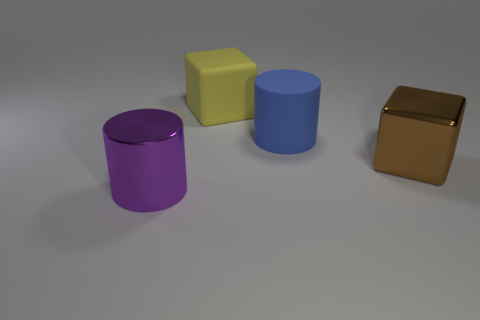Are there any other things that have the same size as the yellow rubber thing? The objects appear to be of varying sizes and proportions. While the yellow block looks unique in its dimensions, it's hard to provide an exact comparison without specific measurements. However, the objects might share similarities in size, such as height or width, when viewed from certain angles or if compared to specific parts of each object. 